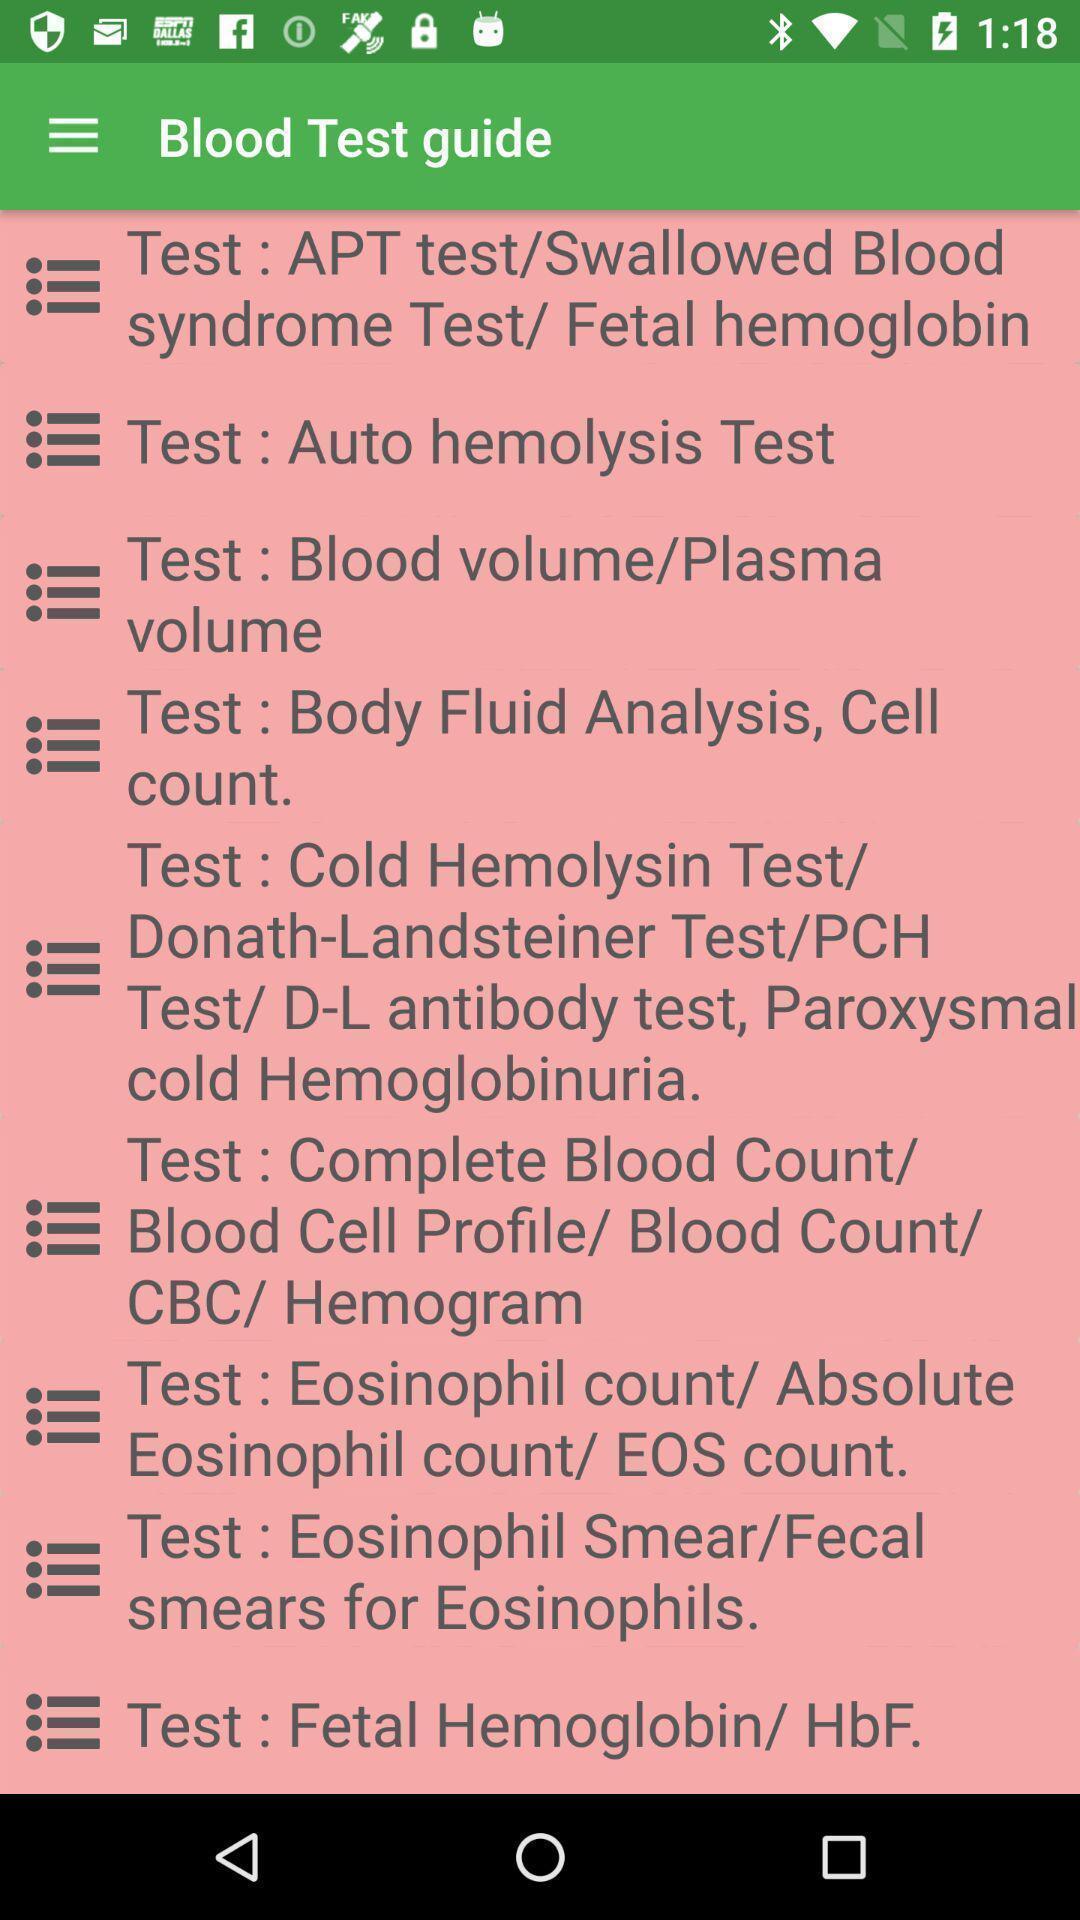Provide a description of this screenshot. Page that displaying medical application. 